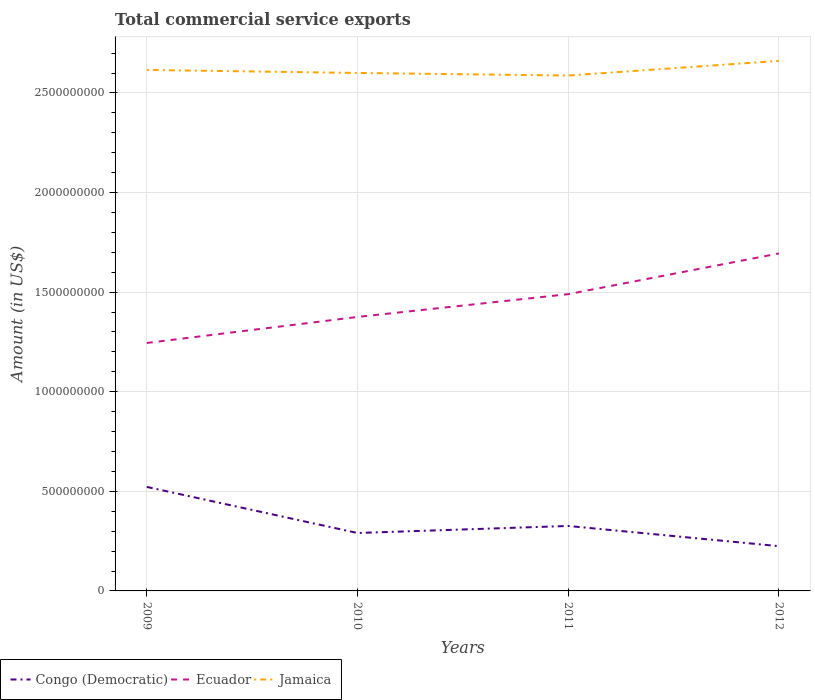How many different coloured lines are there?
Offer a terse response. 3. Does the line corresponding to Jamaica intersect with the line corresponding to Congo (Democratic)?
Provide a succinct answer. No. Is the number of lines equal to the number of legend labels?
Give a very brief answer. Yes. Across all years, what is the maximum total commercial service exports in Congo (Democratic)?
Offer a very short reply. 2.25e+08. In which year was the total commercial service exports in Congo (Democratic) maximum?
Your answer should be very brief. 2012. What is the total total commercial service exports in Congo (Democratic) in the graph?
Your answer should be very brief. -3.54e+07. What is the difference between the highest and the second highest total commercial service exports in Congo (Democratic)?
Give a very brief answer. 2.97e+08. How many years are there in the graph?
Your answer should be compact. 4. Does the graph contain grids?
Your answer should be compact. Yes. What is the title of the graph?
Ensure brevity in your answer.  Total commercial service exports. Does "Kazakhstan" appear as one of the legend labels in the graph?
Offer a very short reply. No. What is the Amount (in US$) of Congo (Democratic) in 2009?
Keep it short and to the point. 5.22e+08. What is the Amount (in US$) in Ecuador in 2009?
Keep it short and to the point. 1.24e+09. What is the Amount (in US$) of Jamaica in 2009?
Your answer should be very brief. 2.62e+09. What is the Amount (in US$) in Congo (Democratic) in 2010?
Your answer should be very brief. 2.91e+08. What is the Amount (in US$) in Ecuador in 2010?
Provide a succinct answer. 1.38e+09. What is the Amount (in US$) in Jamaica in 2010?
Provide a short and direct response. 2.60e+09. What is the Amount (in US$) of Congo (Democratic) in 2011?
Give a very brief answer. 3.26e+08. What is the Amount (in US$) of Ecuador in 2011?
Offer a very short reply. 1.49e+09. What is the Amount (in US$) of Jamaica in 2011?
Your response must be concise. 2.59e+09. What is the Amount (in US$) of Congo (Democratic) in 2012?
Give a very brief answer. 2.25e+08. What is the Amount (in US$) of Ecuador in 2012?
Provide a short and direct response. 1.69e+09. What is the Amount (in US$) of Jamaica in 2012?
Provide a short and direct response. 2.66e+09. Across all years, what is the maximum Amount (in US$) in Congo (Democratic)?
Your response must be concise. 5.22e+08. Across all years, what is the maximum Amount (in US$) in Ecuador?
Provide a succinct answer. 1.69e+09. Across all years, what is the maximum Amount (in US$) in Jamaica?
Offer a very short reply. 2.66e+09. Across all years, what is the minimum Amount (in US$) of Congo (Democratic)?
Provide a succinct answer. 2.25e+08. Across all years, what is the minimum Amount (in US$) of Ecuador?
Your answer should be very brief. 1.24e+09. Across all years, what is the minimum Amount (in US$) in Jamaica?
Your answer should be very brief. 2.59e+09. What is the total Amount (in US$) of Congo (Democratic) in the graph?
Make the answer very short. 1.36e+09. What is the total Amount (in US$) of Ecuador in the graph?
Your response must be concise. 5.80e+09. What is the total Amount (in US$) of Jamaica in the graph?
Keep it short and to the point. 1.05e+1. What is the difference between the Amount (in US$) of Congo (Democratic) in 2009 and that in 2010?
Give a very brief answer. 2.31e+08. What is the difference between the Amount (in US$) of Ecuador in 2009 and that in 2010?
Your response must be concise. -1.31e+08. What is the difference between the Amount (in US$) of Jamaica in 2009 and that in 2010?
Your response must be concise. 1.51e+07. What is the difference between the Amount (in US$) of Congo (Democratic) in 2009 and that in 2011?
Keep it short and to the point. 1.96e+08. What is the difference between the Amount (in US$) of Ecuador in 2009 and that in 2011?
Your answer should be very brief. -2.45e+08. What is the difference between the Amount (in US$) in Jamaica in 2009 and that in 2011?
Offer a terse response. 2.81e+07. What is the difference between the Amount (in US$) in Congo (Democratic) in 2009 and that in 2012?
Give a very brief answer. 2.97e+08. What is the difference between the Amount (in US$) of Ecuador in 2009 and that in 2012?
Your answer should be very brief. -4.49e+08. What is the difference between the Amount (in US$) of Jamaica in 2009 and that in 2012?
Provide a succinct answer. -4.57e+07. What is the difference between the Amount (in US$) of Congo (Democratic) in 2010 and that in 2011?
Ensure brevity in your answer.  -3.54e+07. What is the difference between the Amount (in US$) of Ecuador in 2010 and that in 2011?
Give a very brief answer. -1.14e+08. What is the difference between the Amount (in US$) of Jamaica in 2010 and that in 2011?
Offer a terse response. 1.30e+07. What is the difference between the Amount (in US$) in Congo (Democratic) in 2010 and that in 2012?
Keep it short and to the point. 6.61e+07. What is the difference between the Amount (in US$) of Ecuador in 2010 and that in 2012?
Keep it short and to the point. -3.19e+08. What is the difference between the Amount (in US$) in Jamaica in 2010 and that in 2012?
Your answer should be compact. -6.08e+07. What is the difference between the Amount (in US$) in Congo (Democratic) in 2011 and that in 2012?
Offer a terse response. 1.01e+08. What is the difference between the Amount (in US$) in Ecuador in 2011 and that in 2012?
Provide a short and direct response. -2.04e+08. What is the difference between the Amount (in US$) of Jamaica in 2011 and that in 2012?
Provide a short and direct response. -7.38e+07. What is the difference between the Amount (in US$) in Congo (Democratic) in 2009 and the Amount (in US$) in Ecuador in 2010?
Make the answer very short. -8.53e+08. What is the difference between the Amount (in US$) of Congo (Democratic) in 2009 and the Amount (in US$) of Jamaica in 2010?
Provide a succinct answer. -2.08e+09. What is the difference between the Amount (in US$) of Ecuador in 2009 and the Amount (in US$) of Jamaica in 2010?
Keep it short and to the point. -1.36e+09. What is the difference between the Amount (in US$) of Congo (Democratic) in 2009 and the Amount (in US$) of Ecuador in 2011?
Your answer should be very brief. -9.68e+08. What is the difference between the Amount (in US$) in Congo (Democratic) in 2009 and the Amount (in US$) in Jamaica in 2011?
Give a very brief answer. -2.07e+09. What is the difference between the Amount (in US$) of Ecuador in 2009 and the Amount (in US$) of Jamaica in 2011?
Give a very brief answer. -1.34e+09. What is the difference between the Amount (in US$) in Congo (Democratic) in 2009 and the Amount (in US$) in Ecuador in 2012?
Your answer should be compact. -1.17e+09. What is the difference between the Amount (in US$) of Congo (Democratic) in 2009 and the Amount (in US$) of Jamaica in 2012?
Your response must be concise. -2.14e+09. What is the difference between the Amount (in US$) in Ecuador in 2009 and the Amount (in US$) in Jamaica in 2012?
Give a very brief answer. -1.42e+09. What is the difference between the Amount (in US$) in Congo (Democratic) in 2010 and the Amount (in US$) in Ecuador in 2011?
Offer a very short reply. -1.20e+09. What is the difference between the Amount (in US$) in Congo (Democratic) in 2010 and the Amount (in US$) in Jamaica in 2011?
Your answer should be compact. -2.30e+09. What is the difference between the Amount (in US$) of Ecuador in 2010 and the Amount (in US$) of Jamaica in 2011?
Provide a succinct answer. -1.21e+09. What is the difference between the Amount (in US$) of Congo (Democratic) in 2010 and the Amount (in US$) of Ecuador in 2012?
Your answer should be compact. -1.40e+09. What is the difference between the Amount (in US$) in Congo (Democratic) in 2010 and the Amount (in US$) in Jamaica in 2012?
Your answer should be very brief. -2.37e+09. What is the difference between the Amount (in US$) of Ecuador in 2010 and the Amount (in US$) of Jamaica in 2012?
Offer a terse response. -1.29e+09. What is the difference between the Amount (in US$) in Congo (Democratic) in 2011 and the Amount (in US$) in Ecuador in 2012?
Ensure brevity in your answer.  -1.37e+09. What is the difference between the Amount (in US$) in Congo (Democratic) in 2011 and the Amount (in US$) in Jamaica in 2012?
Ensure brevity in your answer.  -2.34e+09. What is the difference between the Amount (in US$) of Ecuador in 2011 and the Amount (in US$) of Jamaica in 2012?
Keep it short and to the point. -1.17e+09. What is the average Amount (in US$) of Congo (Democratic) per year?
Your response must be concise. 3.41e+08. What is the average Amount (in US$) of Ecuador per year?
Provide a succinct answer. 1.45e+09. What is the average Amount (in US$) in Jamaica per year?
Offer a terse response. 2.62e+09. In the year 2009, what is the difference between the Amount (in US$) in Congo (Democratic) and Amount (in US$) in Ecuador?
Your answer should be compact. -7.23e+08. In the year 2009, what is the difference between the Amount (in US$) of Congo (Democratic) and Amount (in US$) of Jamaica?
Your response must be concise. -2.09e+09. In the year 2009, what is the difference between the Amount (in US$) of Ecuador and Amount (in US$) of Jamaica?
Provide a short and direct response. -1.37e+09. In the year 2010, what is the difference between the Amount (in US$) of Congo (Democratic) and Amount (in US$) of Ecuador?
Provide a short and direct response. -1.08e+09. In the year 2010, what is the difference between the Amount (in US$) of Congo (Democratic) and Amount (in US$) of Jamaica?
Ensure brevity in your answer.  -2.31e+09. In the year 2010, what is the difference between the Amount (in US$) of Ecuador and Amount (in US$) of Jamaica?
Provide a succinct answer. -1.22e+09. In the year 2011, what is the difference between the Amount (in US$) of Congo (Democratic) and Amount (in US$) of Ecuador?
Offer a terse response. -1.16e+09. In the year 2011, what is the difference between the Amount (in US$) in Congo (Democratic) and Amount (in US$) in Jamaica?
Keep it short and to the point. -2.26e+09. In the year 2011, what is the difference between the Amount (in US$) of Ecuador and Amount (in US$) of Jamaica?
Provide a succinct answer. -1.10e+09. In the year 2012, what is the difference between the Amount (in US$) of Congo (Democratic) and Amount (in US$) of Ecuador?
Provide a short and direct response. -1.47e+09. In the year 2012, what is the difference between the Amount (in US$) in Congo (Democratic) and Amount (in US$) in Jamaica?
Keep it short and to the point. -2.44e+09. In the year 2012, what is the difference between the Amount (in US$) of Ecuador and Amount (in US$) of Jamaica?
Offer a very short reply. -9.67e+08. What is the ratio of the Amount (in US$) in Congo (Democratic) in 2009 to that in 2010?
Your answer should be very brief. 1.8. What is the ratio of the Amount (in US$) in Ecuador in 2009 to that in 2010?
Keep it short and to the point. 0.91. What is the ratio of the Amount (in US$) of Jamaica in 2009 to that in 2010?
Offer a very short reply. 1.01. What is the ratio of the Amount (in US$) in Congo (Democratic) in 2009 to that in 2011?
Offer a very short reply. 1.6. What is the ratio of the Amount (in US$) of Ecuador in 2009 to that in 2011?
Your response must be concise. 0.84. What is the ratio of the Amount (in US$) of Jamaica in 2009 to that in 2011?
Offer a very short reply. 1.01. What is the ratio of the Amount (in US$) in Congo (Democratic) in 2009 to that in 2012?
Your answer should be very brief. 2.32. What is the ratio of the Amount (in US$) of Ecuador in 2009 to that in 2012?
Keep it short and to the point. 0.73. What is the ratio of the Amount (in US$) in Jamaica in 2009 to that in 2012?
Keep it short and to the point. 0.98. What is the ratio of the Amount (in US$) in Congo (Democratic) in 2010 to that in 2011?
Make the answer very short. 0.89. What is the ratio of the Amount (in US$) of Ecuador in 2010 to that in 2011?
Your response must be concise. 0.92. What is the ratio of the Amount (in US$) of Jamaica in 2010 to that in 2011?
Offer a very short reply. 1. What is the ratio of the Amount (in US$) of Congo (Democratic) in 2010 to that in 2012?
Your answer should be compact. 1.29. What is the ratio of the Amount (in US$) of Ecuador in 2010 to that in 2012?
Your answer should be very brief. 0.81. What is the ratio of the Amount (in US$) of Jamaica in 2010 to that in 2012?
Your answer should be compact. 0.98. What is the ratio of the Amount (in US$) in Congo (Democratic) in 2011 to that in 2012?
Provide a succinct answer. 1.45. What is the ratio of the Amount (in US$) of Ecuador in 2011 to that in 2012?
Keep it short and to the point. 0.88. What is the ratio of the Amount (in US$) of Jamaica in 2011 to that in 2012?
Your answer should be very brief. 0.97. What is the difference between the highest and the second highest Amount (in US$) in Congo (Democratic)?
Your response must be concise. 1.96e+08. What is the difference between the highest and the second highest Amount (in US$) in Ecuador?
Your answer should be very brief. 2.04e+08. What is the difference between the highest and the second highest Amount (in US$) of Jamaica?
Ensure brevity in your answer.  4.57e+07. What is the difference between the highest and the lowest Amount (in US$) in Congo (Democratic)?
Your response must be concise. 2.97e+08. What is the difference between the highest and the lowest Amount (in US$) in Ecuador?
Offer a very short reply. 4.49e+08. What is the difference between the highest and the lowest Amount (in US$) in Jamaica?
Your answer should be very brief. 7.38e+07. 